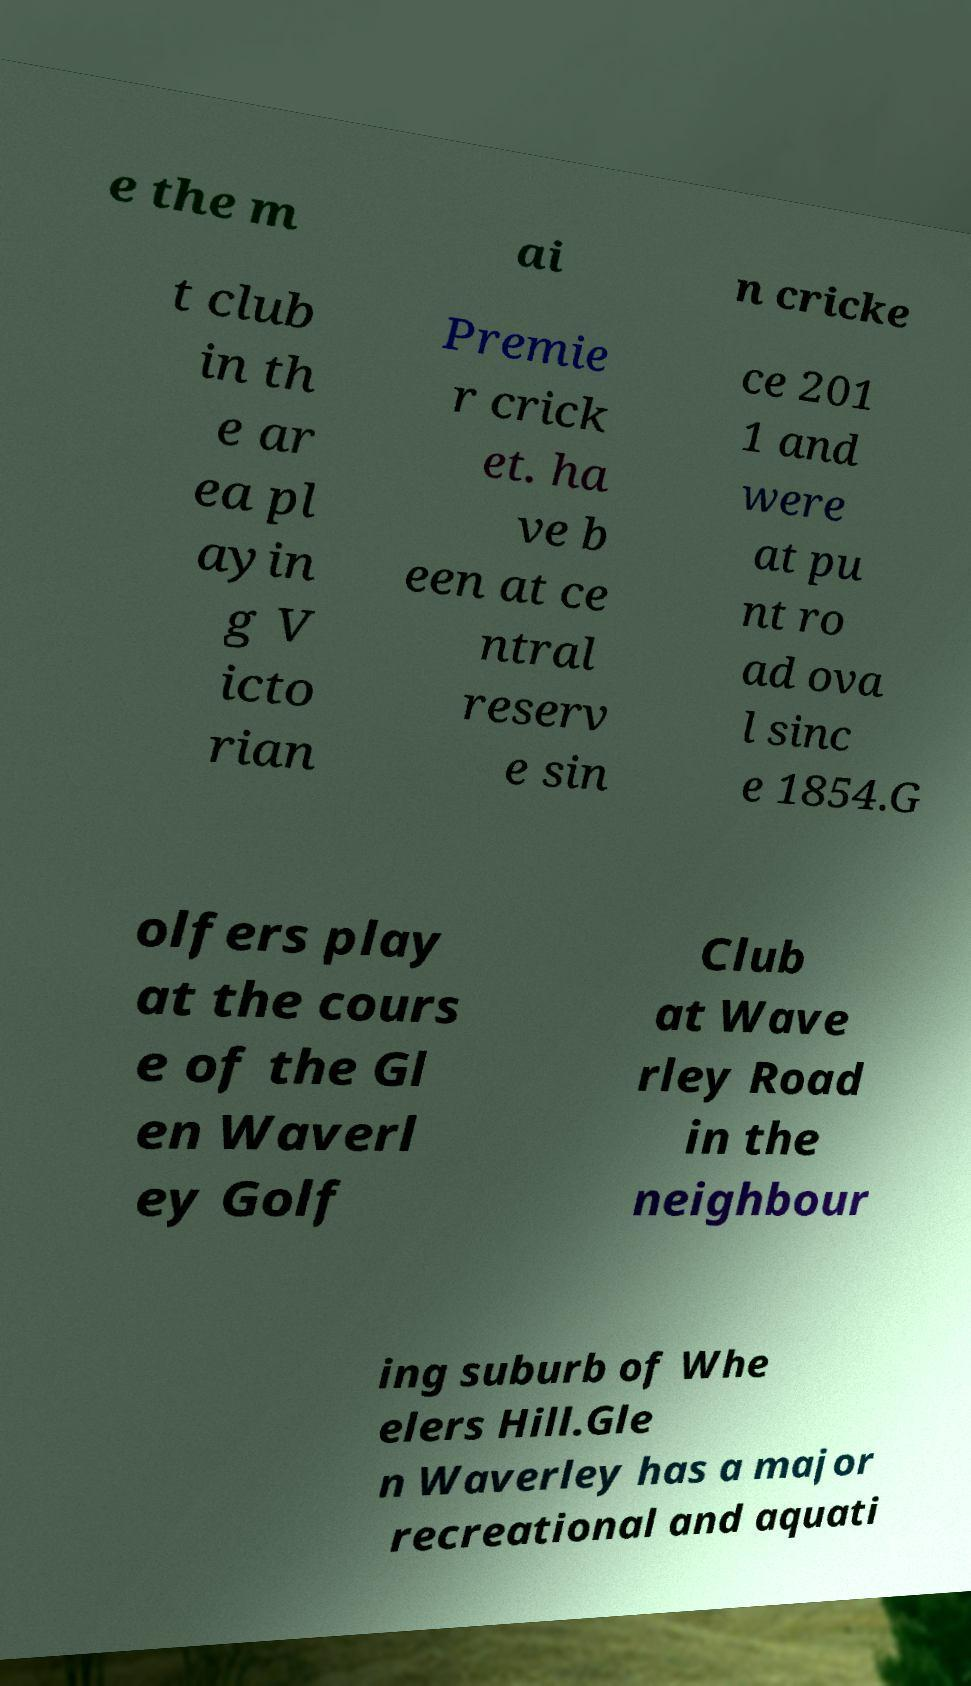What messages or text are displayed in this image? I need them in a readable, typed format. e the m ai n cricke t club in th e ar ea pl ayin g V icto rian Premie r crick et. ha ve b een at ce ntral reserv e sin ce 201 1 and were at pu nt ro ad ova l sinc e 1854.G olfers play at the cours e of the Gl en Waverl ey Golf Club at Wave rley Road in the neighbour ing suburb of Whe elers Hill.Gle n Waverley has a major recreational and aquati 